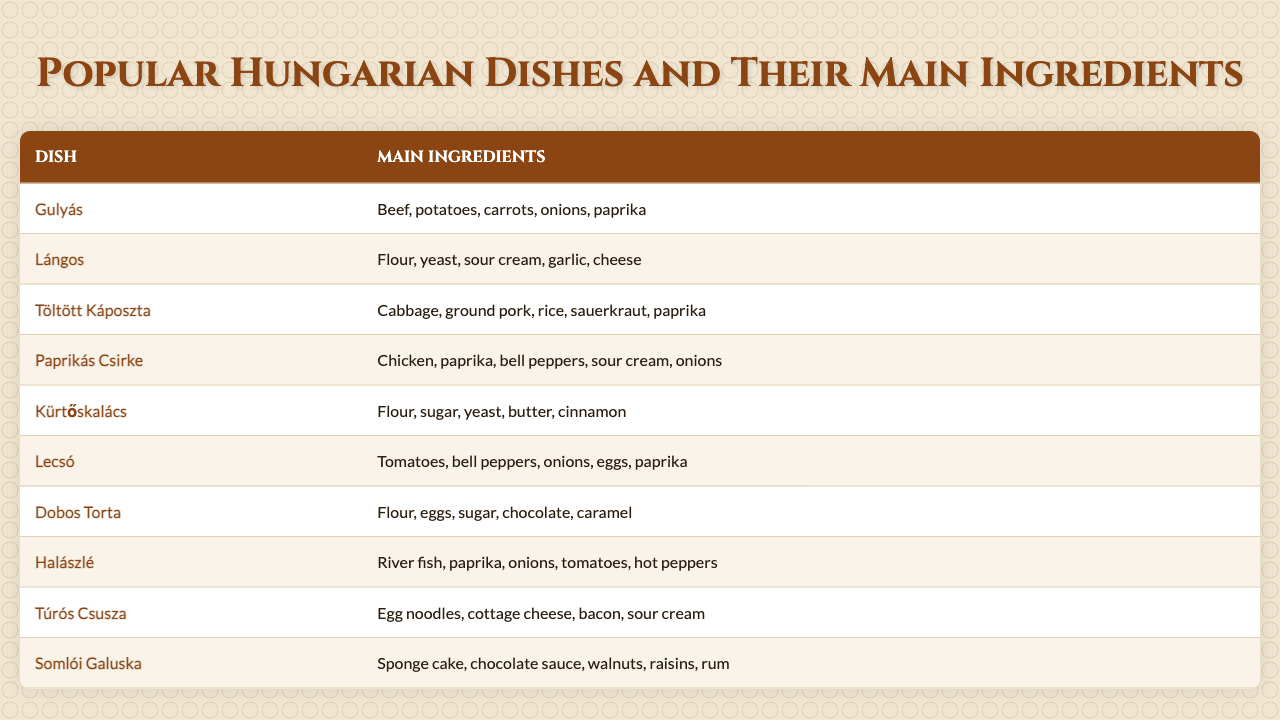What are the main ingredients of Paprikás Csirke? Referring to the table, Paprikás Csirke has the main ingredients of chicken, paprika, bell peppers, sour cream, and onions listed under it.
Answer: Chicken, paprika, bell peppers, sour cream, onions Which dish contains both yogurt and paprika? Scanning through the table, there are no dishes that list yogurt as an ingredient. However, the dish Lángos includes sour cream and Paprikás Csirke contains paprika, but they are not in the same dish.
Answer: No How many dishes contain the ingredient paprika? By looking at the list, Gulyás, Töltött Káposzta, Paprikás Csirke, Lecsó, Halászlé, and Kürtőskalács all list paprika as an ingredient. Counting these gives a total of 5 dishes.
Answer: 5 List the ingredients in Kürtőskalács. The table shows that Kürtőskalács includes flour, sugar, yeast, butter, and cinnamon as its ingredients.
Answer: Flour, sugar, yeast, butter, cinnamon Which dish has the most complex ingredient list? Analyzing the ingredient lists, Töltött Káposzta contains 5 distinct ingredients compared to other dishes. This includes cabbage, ground pork, rice, sauerkraut, and paprika.
Answer: Töltött Káposzta Is there a dish that features eggs as an ingredient? The table shows that Lecsó contains eggs as one of its main ingredients.
Answer: Yes, Lecsó Which dish has sweet elements in its ingredients list? Reviewing the table reveals that both Dobos Torta and Kürtőskalács contain sweet ingredients, like chocolate and sugar for Dobos Torta, and sugar and cinnamon for Kürtőskalács.
Answer: Dobos Torta, Kürtőskalács What is the total count of main ingredients found in Somlói Galuska? The ingredient list for Somlói Galuska shows that it contains sponge cake, chocolate sauce, walnuts, raisins, and rum, totaling to 5 ingredients.
Answer: 5 Identify all dishes that use cheese as an ingredient. The only dish listed that includes cheese is Túrós Csusza, which features cottage cheese as an ingredient.
Answer: Túrós Csusza Which dishes can be considered vegetarian based on the ingredient lists? Checking the dishes, Lecsó is vegetarian as it contains only vegetables. However, Gulyás, Töltött Káposzta, Paprikás Csirke, Halászlé, and Túrós Csusza contain meat or fish.
Answer: Lecsó 